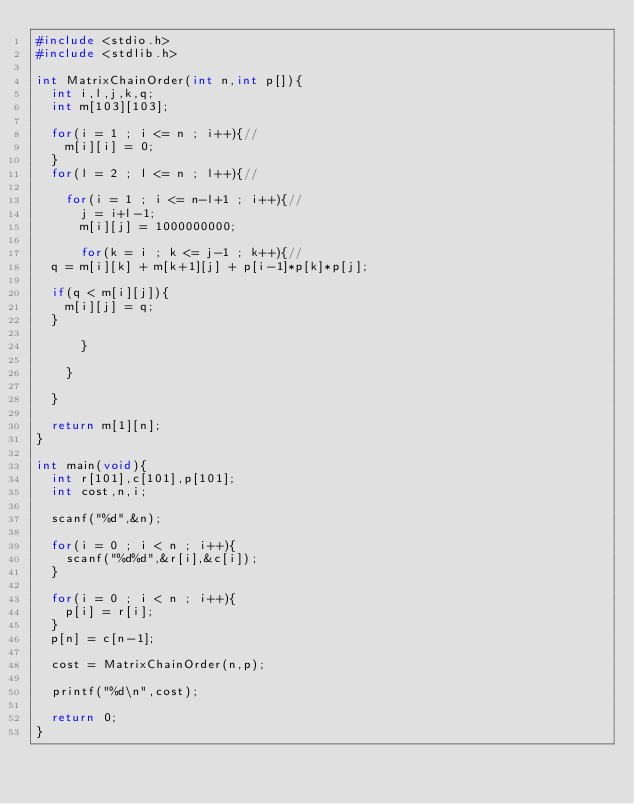Convert code to text. <code><loc_0><loc_0><loc_500><loc_500><_C_>#include <stdio.h>
#include <stdlib.h>

int MatrixChainOrder(int n,int p[]){
  int i,l,j,k,q;
  int m[103][103];

  for(i = 1 ; i <= n ; i++){//
    m[i][i] = 0;
  }
  for(l = 2 ; l <= n ; l++){//
    
    for(i = 1 ; i <= n-l+1 ; i++){//
      j = i+l-1;
      m[i][j] = 1000000000;
  
      for(k = i ; k <= j-1 ; k++){//
	q = m[i][k] + m[k+1][j] + p[i-1]*p[k]*p[j];
	
	if(q < m[i][j]){
	  m[i][j] = q;
	}
	
      }
      
    }
    
  }

  return m[1][n];
}

int main(void){
  int r[101],c[101],p[101];
  int cost,n,i;

  scanf("%d",&n);
  
  for(i = 0 ; i < n ; i++){
    scanf("%d%d",&r[i],&c[i]);
  }
  
  for(i = 0 ; i < n ; i++){
    p[i] = r[i];
  }
  p[n] = c[n-1];
  
  cost = MatrixChainOrder(n,p);

  printf("%d\n",cost);
  
  return 0;
}</code> 